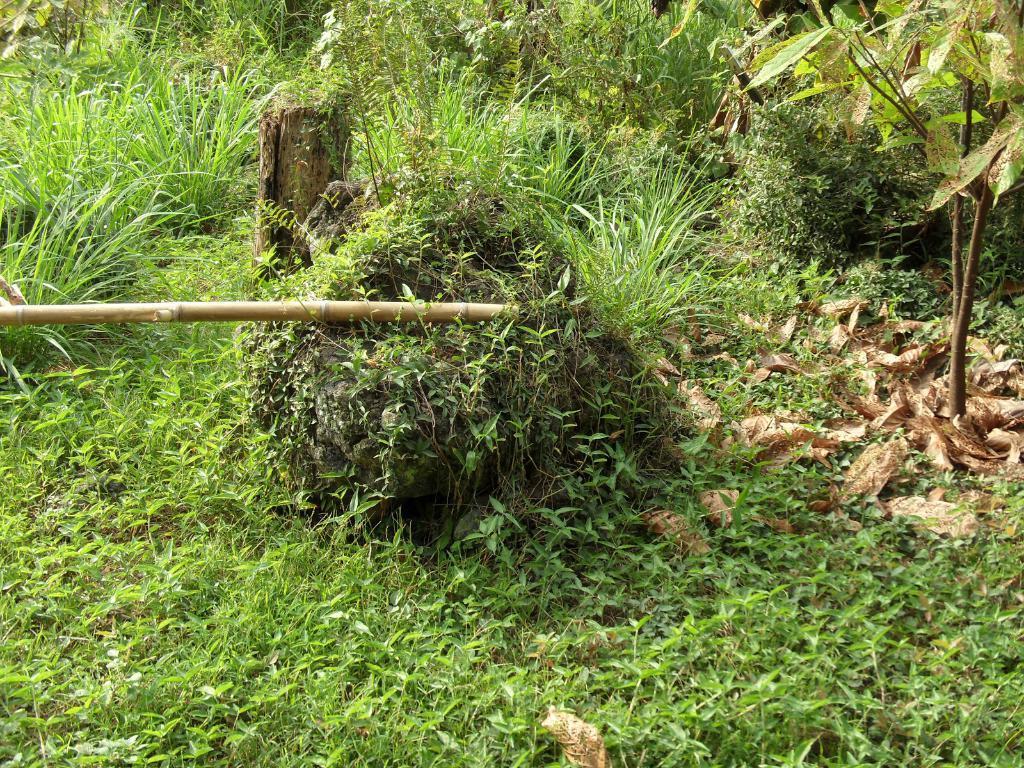Please provide a concise description of this image. In this picture we can see grass at the bottom, there are some plants in the background, we can see a stick on the left side. 